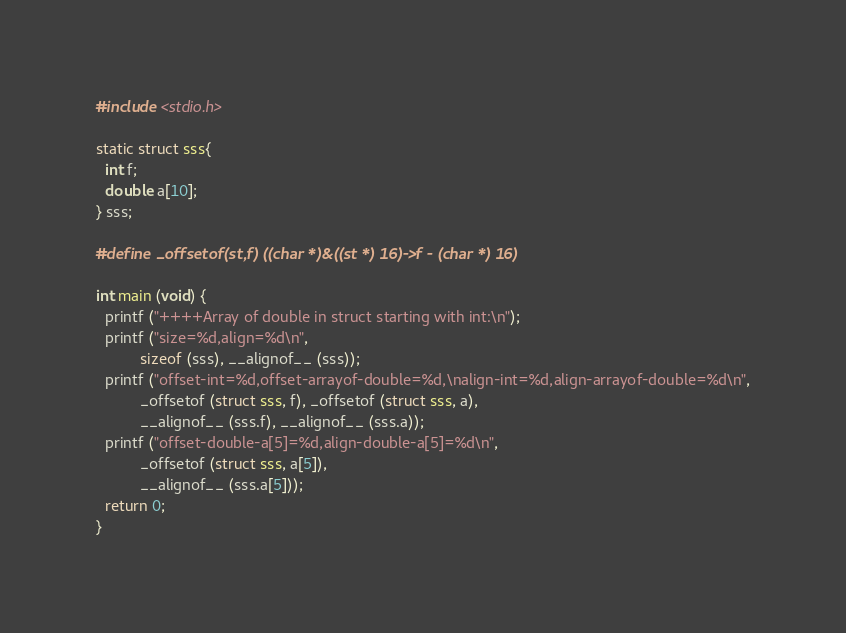<code> <loc_0><loc_0><loc_500><loc_500><_C_>#include <stdio.h>

static struct sss{
  int f;
  double a[10];
} sss;

#define _offsetof(st,f) ((char *)&((st *) 16)->f - (char *) 16)

int main (void) {
  printf ("++++Array of double in struct starting with int:\n");
  printf ("size=%d,align=%d\n",
          sizeof (sss), __alignof__ (sss));
  printf ("offset-int=%d,offset-arrayof-double=%d,\nalign-int=%d,align-arrayof-double=%d\n",
          _offsetof (struct sss, f), _offsetof (struct sss, a),
          __alignof__ (sss.f), __alignof__ (sss.a));
  printf ("offset-double-a[5]=%d,align-double-a[5]=%d\n",
          _offsetof (struct sss, a[5]),
          __alignof__ (sss.a[5]));
  return 0;
}
</code> 